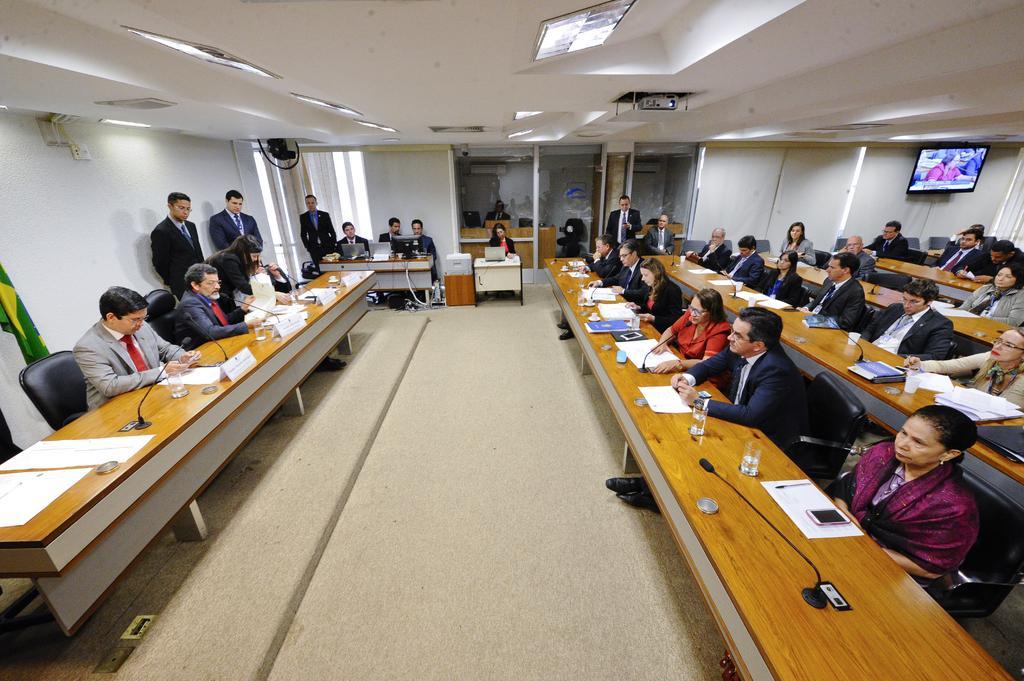In one or two sentences, can you explain what this image depicts? In the middle there is a woman she is staring at laptop. I think this image is clicked in meeting. On the left there is a man he wear suit and tie he is sitting on the chair. In the middle there is a table on the table there is a glass,paper ,mobile and mic stand. On the right there is a television. At the top there is a projector. In this image there are many people 